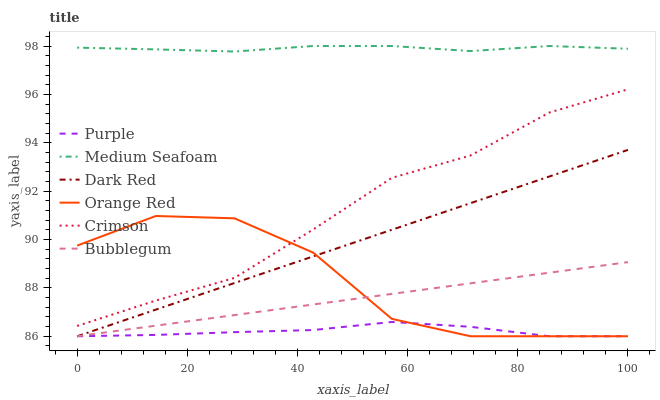Does Purple have the minimum area under the curve?
Answer yes or no. Yes. Does Medium Seafoam have the maximum area under the curve?
Answer yes or no. Yes. Does Dark Red have the minimum area under the curve?
Answer yes or no. No. Does Dark Red have the maximum area under the curve?
Answer yes or no. No. Is Dark Red the smoothest?
Answer yes or no. Yes. Is Orange Red the roughest?
Answer yes or no. Yes. Is Bubblegum the smoothest?
Answer yes or no. No. Is Bubblegum the roughest?
Answer yes or no. No. Does Crimson have the lowest value?
Answer yes or no. No. Does Dark Red have the highest value?
Answer yes or no. No. Is Purple less than Medium Seafoam?
Answer yes or no. Yes. Is Medium Seafoam greater than Crimson?
Answer yes or no. Yes. Does Purple intersect Medium Seafoam?
Answer yes or no. No. 